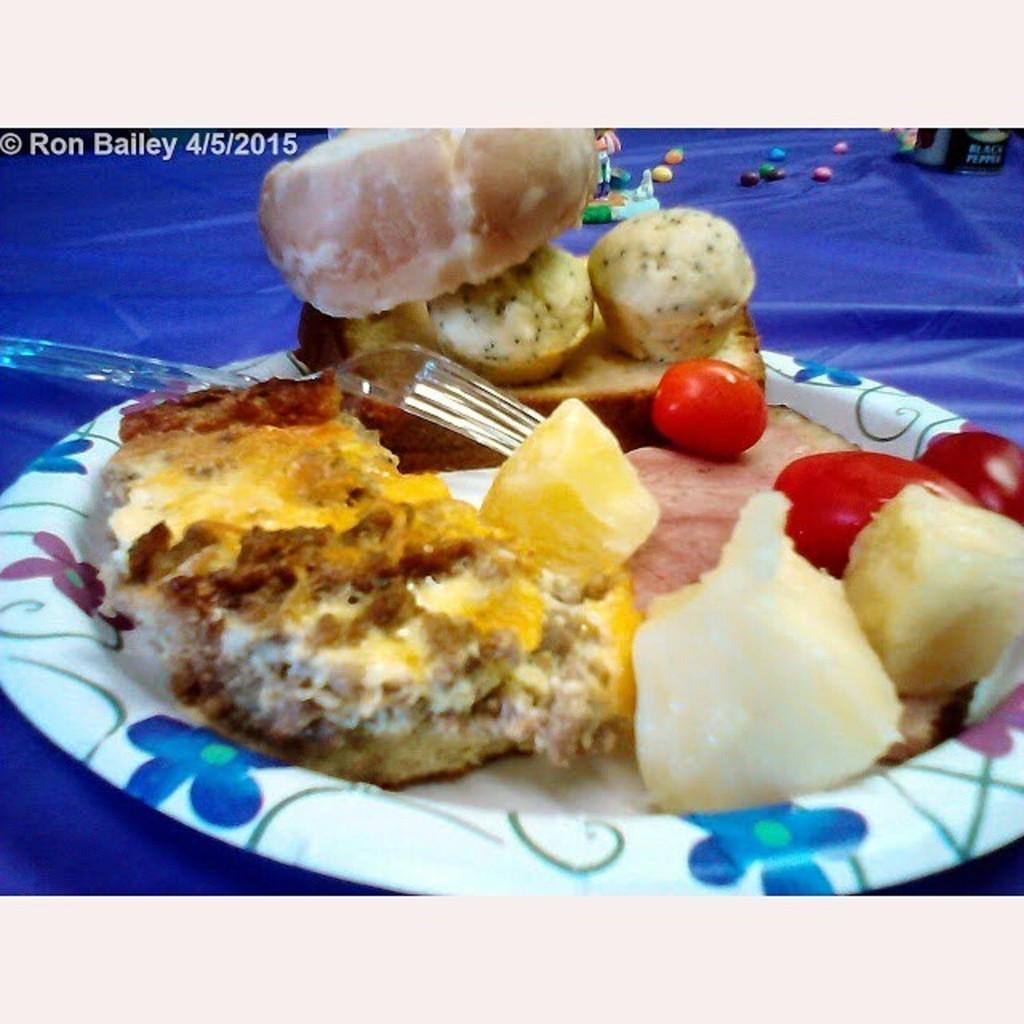How would you summarize this image in a sentence or two? In this image we can see we can see in the plate. There is a cloth below the plate. There are few objects on the cloth. There is a fork in the image. 